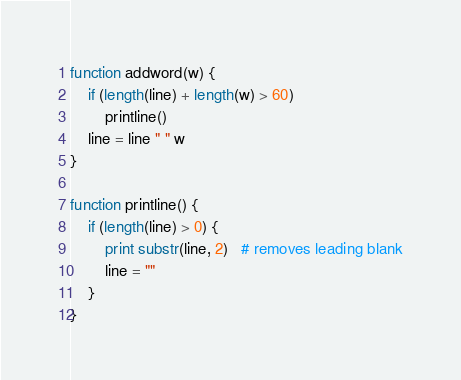Convert code to text. <code><loc_0><loc_0><loc_500><loc_500><_Awk_>
function addword(w) {
    if (length(line) + length(w) > 60)
        printline()
    line = line " " w
}

function printline() {
    if (length(line) > 0) {
        print substr(line, 2)   # removes leading blank
        line = ""
    }
}
</code> 